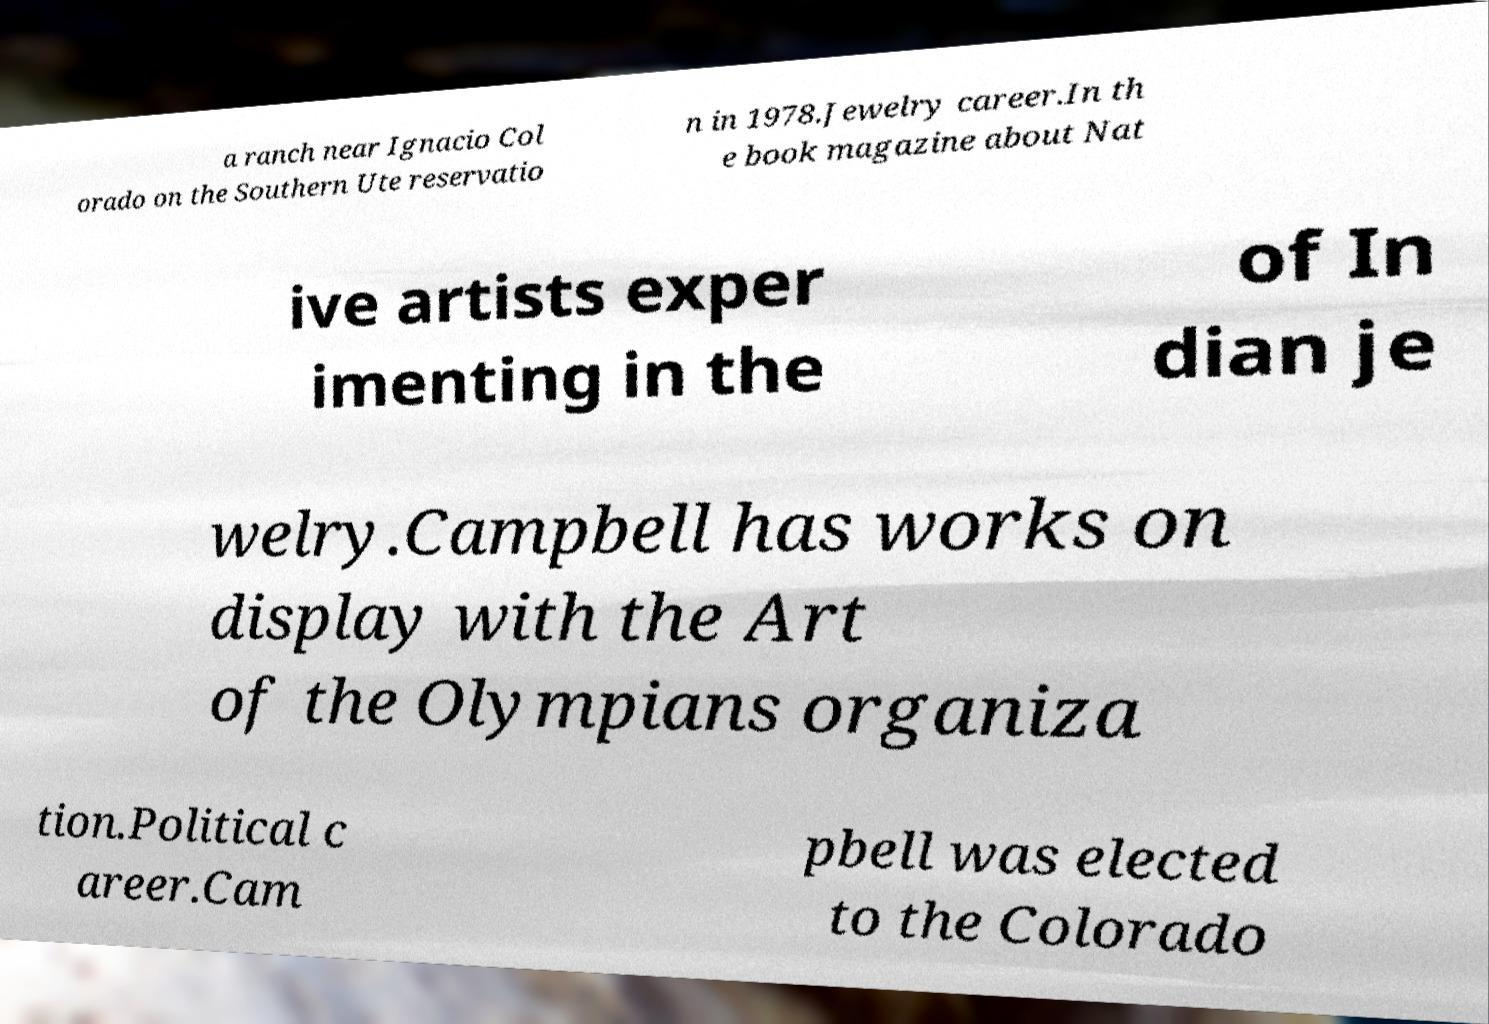For documentation purposes, I need the text within this image transcribed. Could you provide that? a ranch near Ignacio Col orado on the Southern Ute reservatio n in 1978.Jewelry career.In th e book magazine about Nat ive artists exper imenting in the of In dian je welry.Campbell has works on display with the Art of the Olympians organiza tion.Political c areer.Cam pbell was elected to the Colorado 